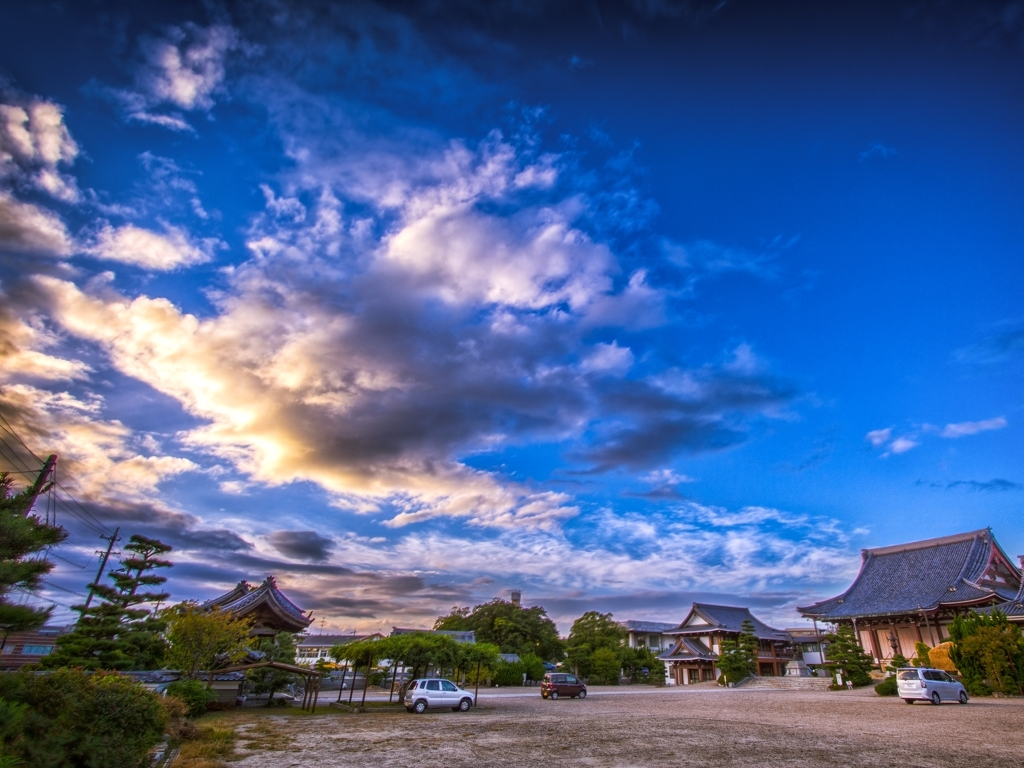Can you describe the architectural style visible in the image and what it might tell us about the culture or history of the place? The architecture in the image exhibits characteristics typical of traditional East Asian styles, such as curved rooflines with upturned eaves, large wooden beams, and intricate brackets. These elements are indicative of a culture that values harmony with nature and attention to detail. Such structures often belong to places of historical significance, suggesting that this site could have been a seat of community, worship, or learning, and has likely been preserved due to its cultural importance. 